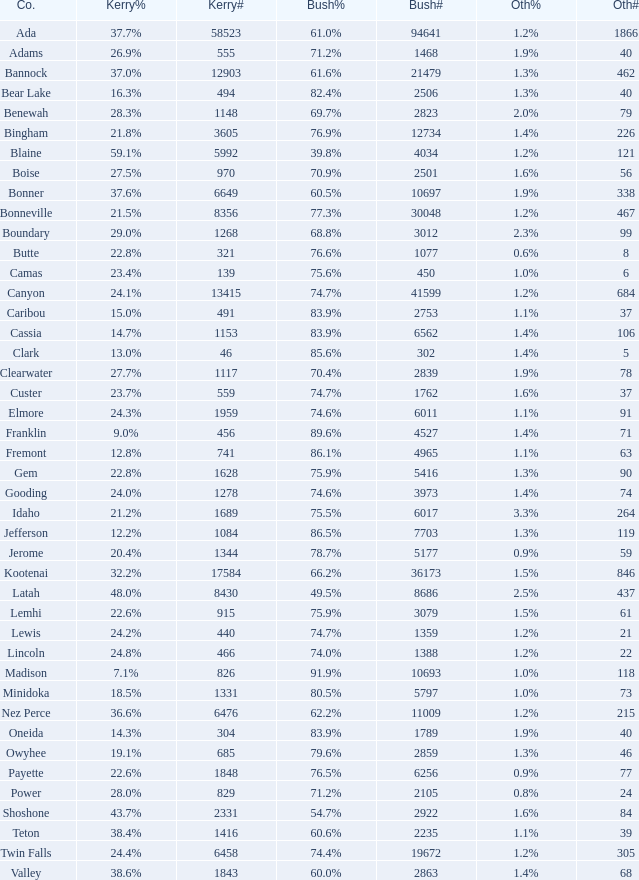What percentage of the votes in Oneida did Kerry win? 14.3%. 